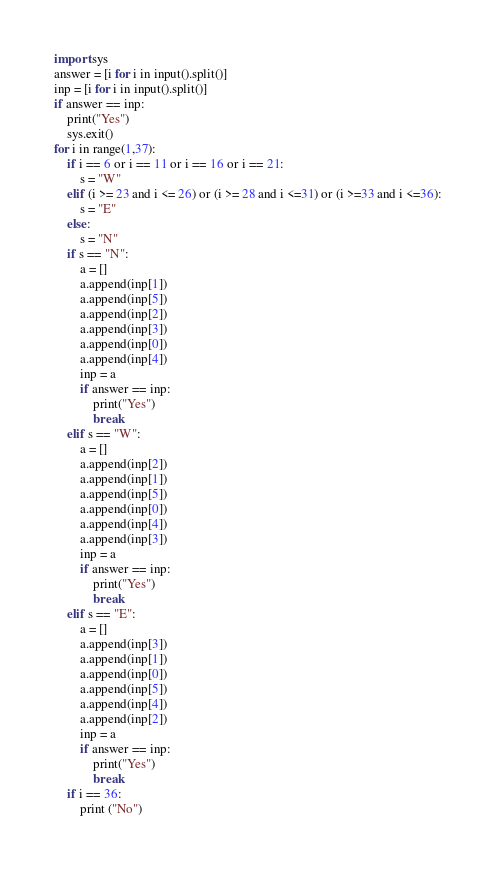<code> <loc_0><loc_0><loc_500><loc_500><_Python_>import sys
answer = [i for i in input().split()]
inp = [i for i in input().split()]
if answer == inp:
    print("Yes")
    sys.exit()
for i in range(1,37):
    if i == 6 or i == 11 or i == 16 or i == 21:
        s = "W"
    elif (i >= 23 and i <= 26) or (i >= 28 and i <=31) or (i >=33 and i <=36):
        s = "E"
    else:
        s = "N"
    if s == "N":
        a = []
        a.append(inp[1])
        a.append(inp[5])
        a.append(inp[2])
        a.append(inp[3])
        a.append(inp[0])
        a.append(inp[4])
        inp = a
        if answer == inp:
            print("Yes")
            break
    elif s == "W":
        a = []
        a.append(inp[2])
        a.append(inp[1])
        a.append(inp[5])
        a.append(inp[0])
        a.append(inp[4])
        a.append(inp[3])
        inp = a
        if answer == inp:
            print("Yes")
            break
    elif s == "E":
        a = []
        a.append(inp[3])
        a.append(inp[1])
        a.append(inp[0])
        a.append(inp[5])
        a.append(inp[4])
        a.append(inp[2])
        inp = a
        if answer == inp:
            print("Yes")
            break
    if i == 36:
        print ("No")</code> 